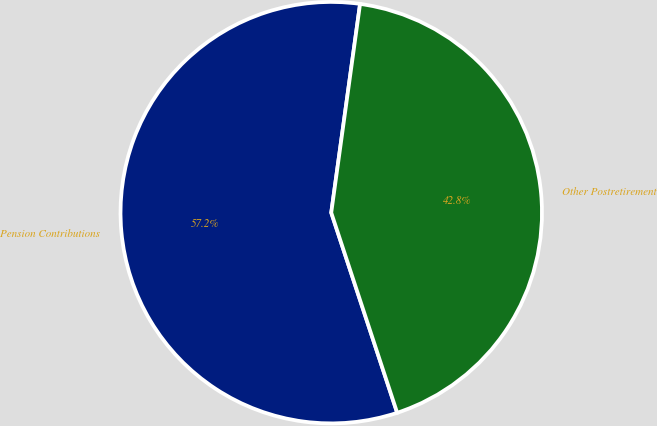Convert chart. <chart><loc_0><loc_0><loc_500><loc_500><pie_chart><fcel>Pension Contributions<fcel>Other Postretirement<nl><fcel>57.25%<fcel>42.75%<nl></chart> 